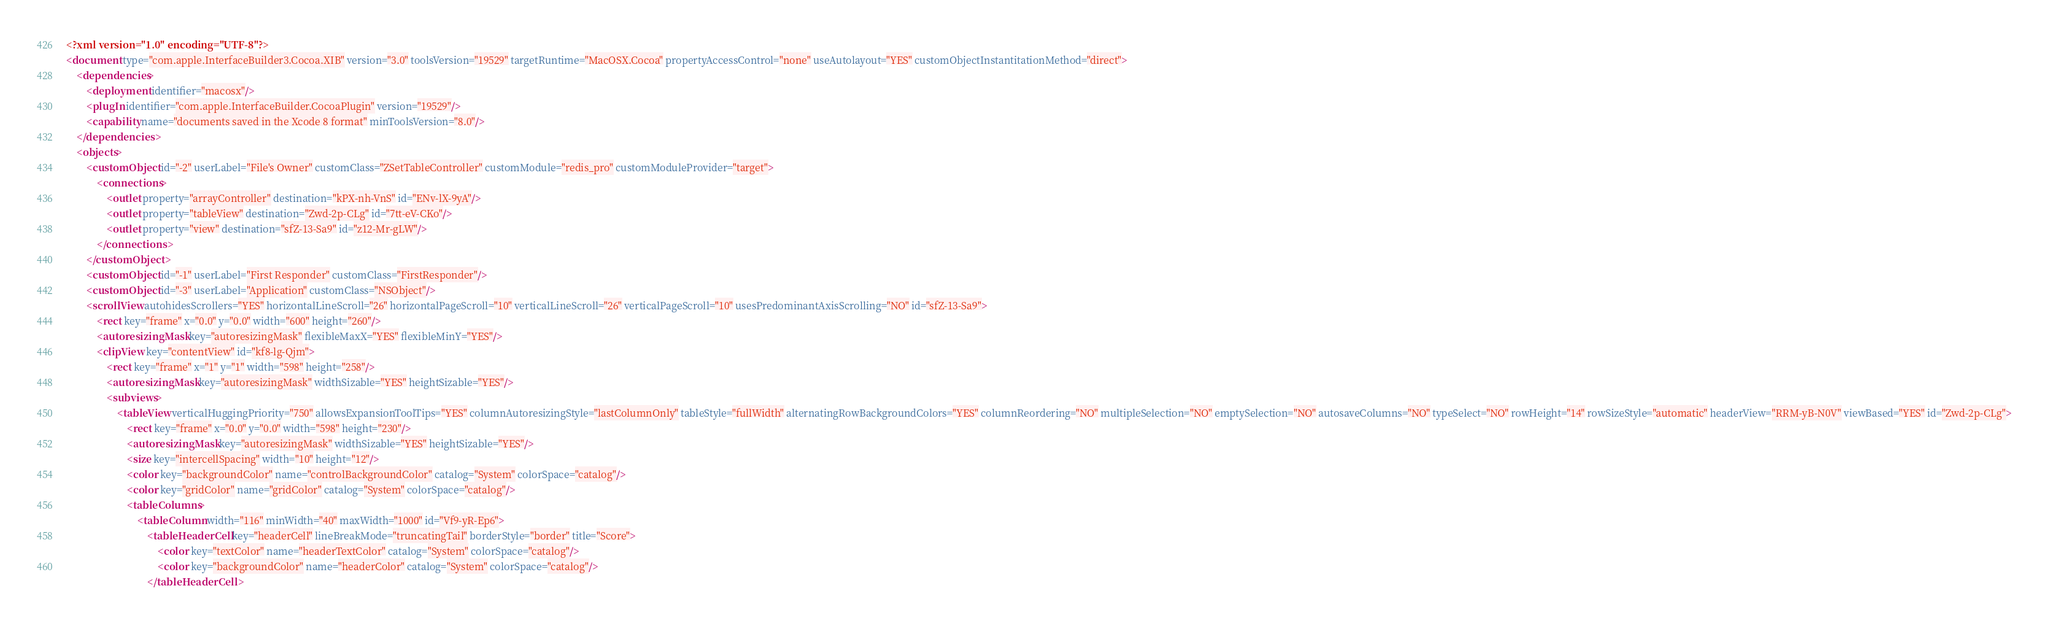Convert code to text. <code><loc_0><loc_0><loc_500><loc_500><_XML_><?xml version="1.0" encoding="UTF-8"?>
<document type="com.apple.InterfaceBuilder3.Cocoa.XIB" version="3.0" toolsVersion="19529" targetRuntime="MacOSX.Cocoa" propertyAccessControl="none" useAutolayout="YES" customObjectInstantitationMethod="direct">
    <dependencies>
        <deployment identifier="macosx"/>
        <plugIn identifier="com.apple.InterfaceBuilder.CocoaPlugin" version="19529"/>
        <capability name="documents saved in the Xcode 8 format" minToolsVersion="8.0"/>
    </dependencies>
    <objects>
        <customObject id="-2" userLabel="File's Owner" customClass="ZSetTableController" customModule="redis_pro" customModuleProvider="target">
            <connections>
                <outlet property="arrayController" destination="kPX-nh-VnS" id="ENv-lX-9yA"/>
                <outlet property="tableView" destination="Zwd-2p-CLg" id="7tt-eV-CKo"/>
                <outlet property="view" destination="sfZ-13-Sa9" id="z12-Mr-gLW"/>
            </connections>
        </customObject>
        <customObject id="-1" userLabel="First Responder" customClass="FirstResponder"/>
        <customObject id="-3" userLabel="Application" customClass="NSObject"/>
        <scrollView autohidesScrollers="YES" horizontalLineScroll="26" horizontalPageScroll="10" verticalLineScroll="26" verticalPageScroll="10" usesPredominantAxisScrolling="NO" id="sfZ-13-Sa9">
            <rect key="frame" x="0.0" y="0.0" width="600" height="260"/>
            <autoresizingMask key="autoresizingMask" flexibleMaxX="YES" flexibleMinY="YES"/>
            <clipView key="contentView" id="kf8-lg-Qjm">
                <rect key="frame" x="1" y="1" width="598" height="258"/>
                <autoresizingMask key="autoresizingMask" widthSizable="YES" heightSizable="YES"/>
                <subviews>
                    <tableView verticalHuggingPriority="750" allowsExpansionToolTips="YES" columnAutoresizingStyle="lastColumnOnly" tableStyle="fullWidth" alternatingRowBackgroundColors="YES" columnReordering="NO" multipleSelection="NO" emptySelection="NO" autosaveColumns="NO" typeSelect="NO" rowHeight="14" rowSizeStyle="automatic" headerView="RRM-yB-N0V" viewBased="YES" id="Zwd-2p-CLg">
                        <rect key="frame" x="0.0" y="0.0" width="598" height="230"/>
                        <autoresizingMask key="autoresizingMask" widthSizable="YES" heightSizable="YES"/>
                        <size key="intercellSpacing" width="10" height="12"/>
                        <color key="backgroundColor" name="controlBackgroundColor" catalog="System" colorSpace="catalog"/>
                        <color key="gridColor" name="gridColor" catalog="System" colorSpace="catalog"/>
                        <tableColumns>
                            <tableColumn width="116" minWidth="40" maxWidth="1000" id="Vf9-yR-Ep6">
                                <tableHeaderCell key="headerCell" lineBreakMode="truncatingTail" borderStyle="border" title="Score">
                                    <color key="textColor" name="headerTextColor" catalog="System" colorSpace="catalog"/>
                                    <color key="backgroundColor" name="headerColor" catalog="System" colorSpace="catalog"/>
                                </tableHeaderCell></code> 